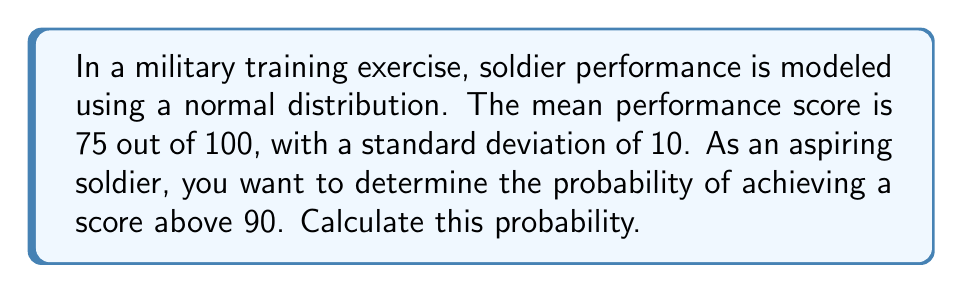Give your solution to this math problem. To solve this problem, we'll use the properties of the normal distribution and the concept of z-scores.

Step 1: Identify the given information
- Mean (μ) = 75
- Standard deviation (σ) = 10
- Target score (x) = 90

Step 2: Calculate the z-score
The z-score represents how many standard deviations a value is from the mean.
$$z = \frac{x - μ}{σ} = \frac{90 - 75}{10} = 1.5$$

Step 3: Use the standard normal distribution table
We need to find P(Z > 1.5), which is equivalent to 1 - P(Z ≤ 1.5).
From the standard normal table, we find that P(Z ≤ 1.5) ≈ 0.9332

Step 4: Calculate the probability
P(score > 90) = 1 - P(Z ≤ 1.5) = 1 - 0.9332 = 0.0668

Step 5: Convert to percentage
0.0668 * 100 = 6.68%

Therefore, the probability of achieving a score above 90 is approximately 6.68%.
Answer: 6.68% 